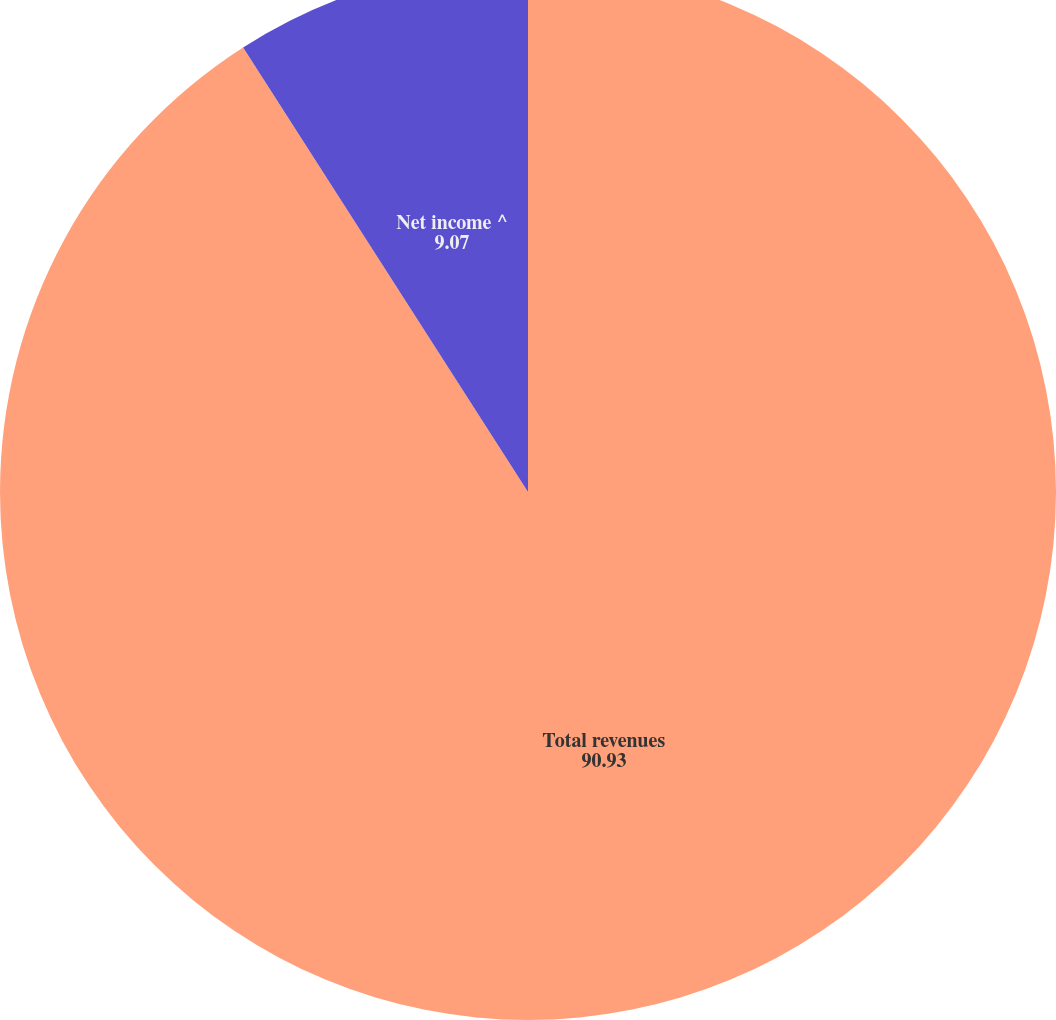Convert chart. <chart><loc_0><loc_0><loc_500><loc_500><pie_chart><fcel>Total revenues<fcel>Net income ^<nl><fcel>90.93%<fcel>9.07%<nl></chart> 